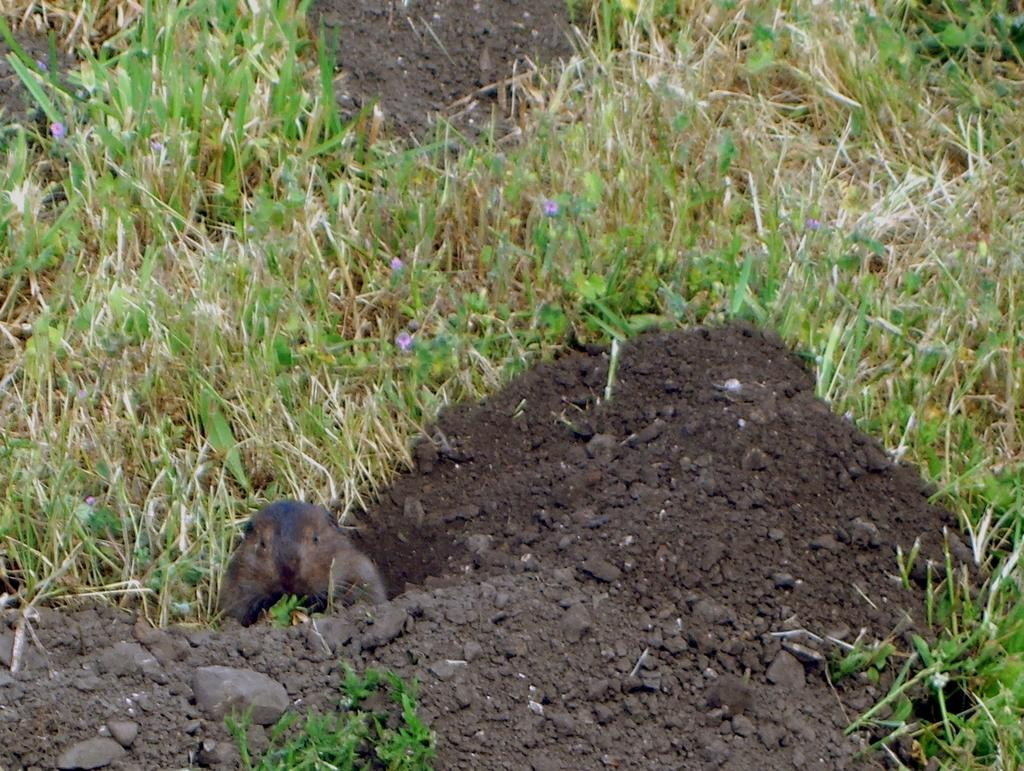What type of living creature is in the image? There is an animal in the image. Where is the animal located in the image? The animal is on the left side of the image. What can be seen at the top of the image? There are flowers at the top of the image. What type of vegetation is present in the image? There are plants in the image. Is the animal wearing a crown in the image? There is no crown present in the image, and the animal is not wearing any accessories. 